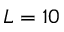Convert formula to latex. <formula><loc_0><loc_0><loc_500><loc_500>L = 1 0</formula> 